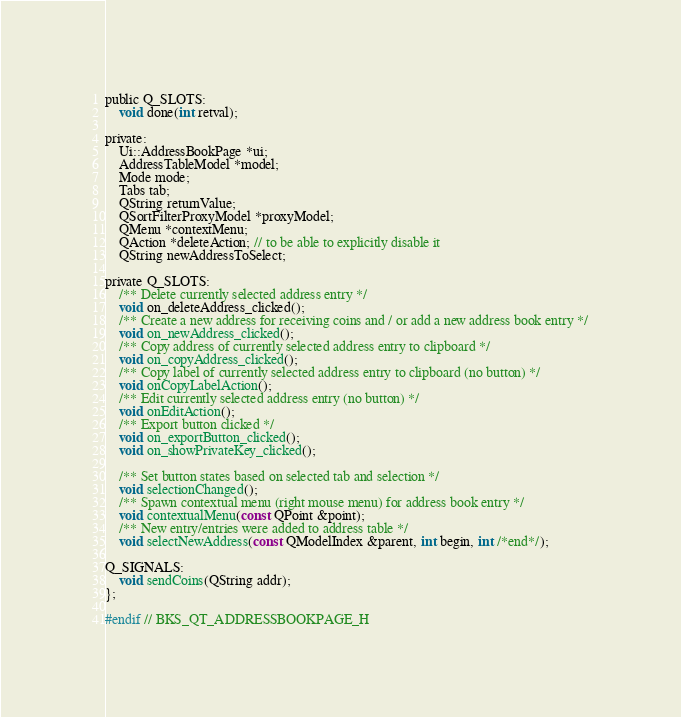<code> <loc_0><loc_0><loc_500><loc_500><_C_>
public Q_SLOTS:
    void done(int retval);

private:
    Ui::AddressBookPage *ui;
    AddressTableModel *model;
    Mode mode;
    Tabs tab;
    QString returnValue;
    QSortFilterProxyModel *proxyModel;
    QMenu *contextMenu;
    QAction *deleteAction; // to be able to explicitly disable it
    QString newAddressToSelect;

private Q_SLOTS:
    /** Delete currently selected address entry */
    void on_deleteAddress_clicked();
    /** Create a new address for receiving coins and / or add a new address book entry */
    void on_newAddress_clicked();
    /** Copy address of currently selected address entry to clipboard */
    void on_copyAddress_clicked();
    /** Copy label of currently selected address entry to clipboard (no button) */
    void onCopyLabelAction();
    /** Edit currently selected address entry (no button) */
    void onEditAction();
    /** Export button clicked */
    void on_exportButton_clicked();
    void on_showPrivateKey_clicked();

    /** Set button states based on selected tab and selection */
    void selectionChanged();
    /** Spawn contextual menu (right mouse menu) for address book entry */
    void contextualMenu(const QPoint &point);
    /** New entry/entries were added to address table */
    void selectNewAddress(const QModelIndex &parent, int begin, int /*end*/);

Q_SIGNALS:
    void sendCoins(QString addr);
};

#endif // BKS_QT_ADDRESSBOOKPAGE_H
</code> 